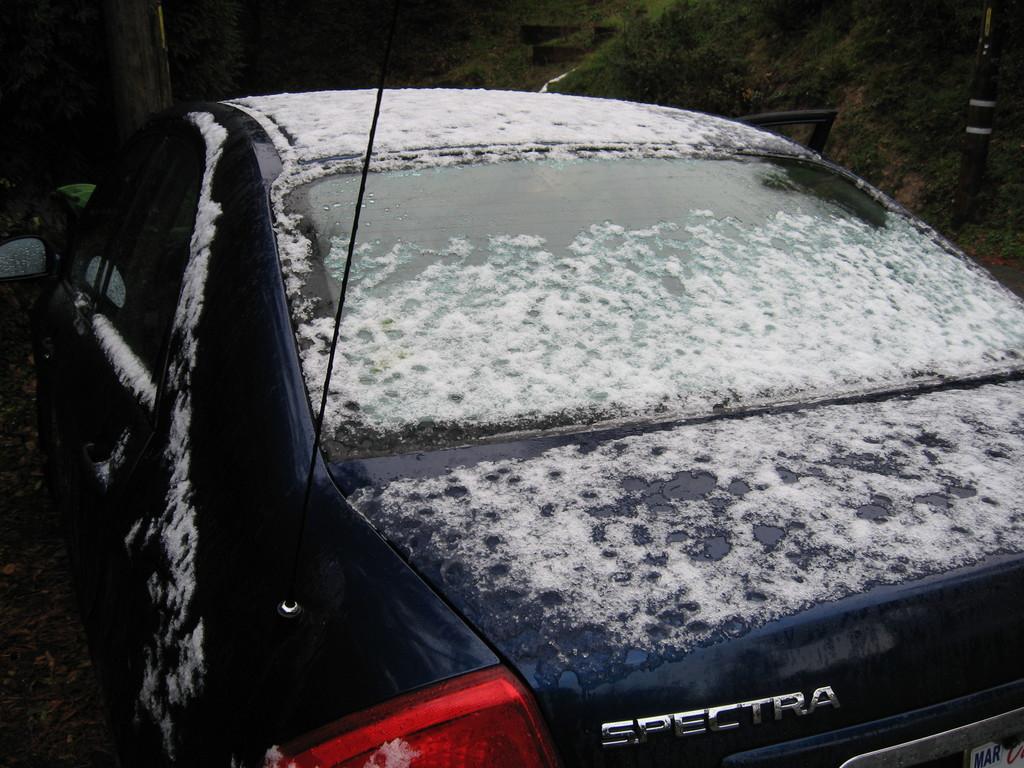Please provide a concise description of this image. In this image I can see there is a car with snow on it. 